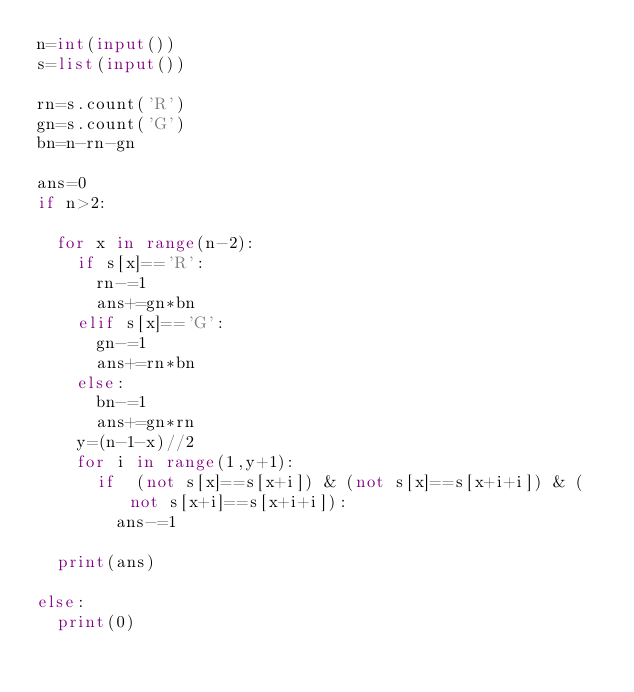<code> <loc_0><loc_0><loc_500><loc_500><_Python_>n=int(input())
s=list(input())

rn=s.count('R')
gn=s.count('G')
bn=n-rn-gn

ans=0
if n>2:
  
  for x in range(n-2):
    if s[x]=='R':
      rn-=1
      ans+=gn*bn
    elif s[x]=='G':
      gn-=1
      ans+=rn*bn
    else:
      bn-=1
      ans+=gn*rn
    y=(n-1-x)//2
    for i in range(1,y+1):
      if  (not s[x]==s[x+i]) & (not s[x]==s[x+i+i]) & (not s[x+i]==s[x+i+i]):
        ans-=1
        
  print(ans)
    
else:
  print(0)</code> 